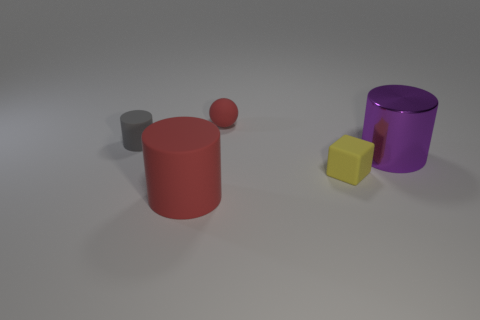What number of small gray things are the same material as the tiny gray cylinder? In the image, there is one small gray cylinder that appears to be the same material as the tiny gray cylinder mentioned. Considering the specific question about the number of small gray things of the same material, the correct answer would be 1. 